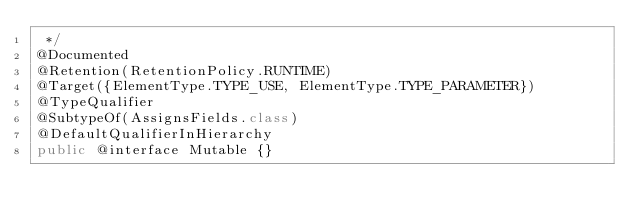Convert code to text. <code><loc_0><loc_0><loc_500><loc_500><_Java_> */
@Documented
@Retention(RetentionPolicy.RUNTIME)
@Target({ElementType.TYPE_USE, ElementType.TYPE_PARAMETER})
@TypeQualifier
@SubtypeOf(AssignsFields.class)
@DefaultQualifierInHierarchy
public @interface Mutable {}
</code> 